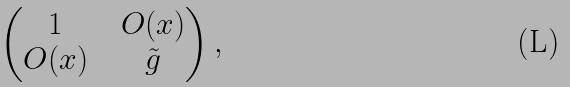<formula> <loc_0><loc_0><loc_500><loc_500>\begin{pmatrix} 1 & & O ( x ) \\ O ( x ) & & \tilde { g } \end{pmatrix} ,</formula> 